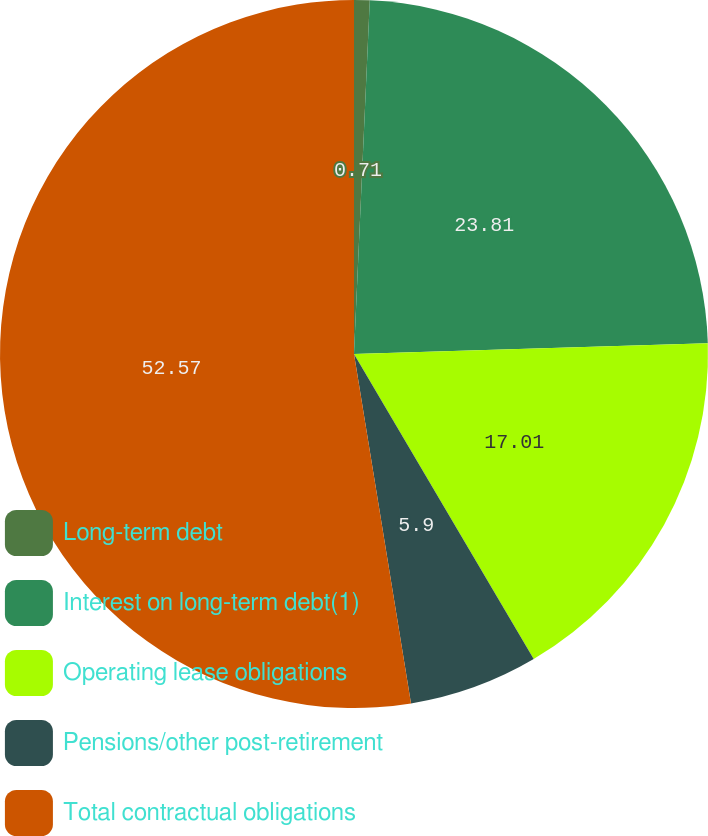<chart> <loc_0><loc_0><loc_500><loc_500><pie_chart><fcel>Long-term debt<fcel>Interest on long-term debt(1)<fcel>Operating lease obligations<fcel>Pensions/other post-retirement<fcel>Total contractual obligations<nl><fcel>0.71%<fcel>23.81%<fcel>17.01%<fcel>5.9%<fcel>52.58%<nl></chart> 